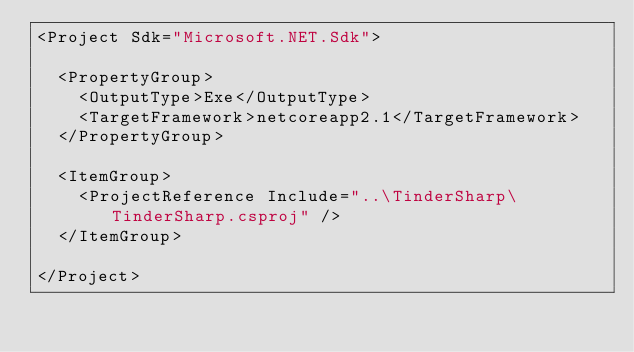<code> <loc_0><loc_0><loc_500><loc_500><_XML_><Project Sdk="Microsoft.NET.Sdk">

  <PropertyGroup>
    <OutputType>Exe</OutputType>
    <TargetFramework>netcoreapp2.1</TargetFramework>
  </PropertyGroup>

  <ItemGroup>
    <ProjectReference Include="..\TinderSharp\TinderSharp.csproj" />
  </ItemGroup>

</Project>
</code> 